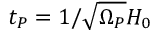<formula> <loc_0><loc_0><loc_500><loc_500>t _ { P } = 1 / \sqrt { \Omega _ { P } } H _ { 0 }</formula> 